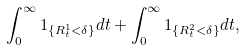Convert formula to latex. <formula><loc_0><loc_0><loc_500><loc_500>\int _ { 0 } ^ { \infty } 1 _ { \{ R ^ { 1 } _ { t } < \delta \} } d t + \int _ { 0 } ^ { \infty } 1 _ { \{ R ^ { 2 } _ { t } < \delta \} } d t ,</formula> 